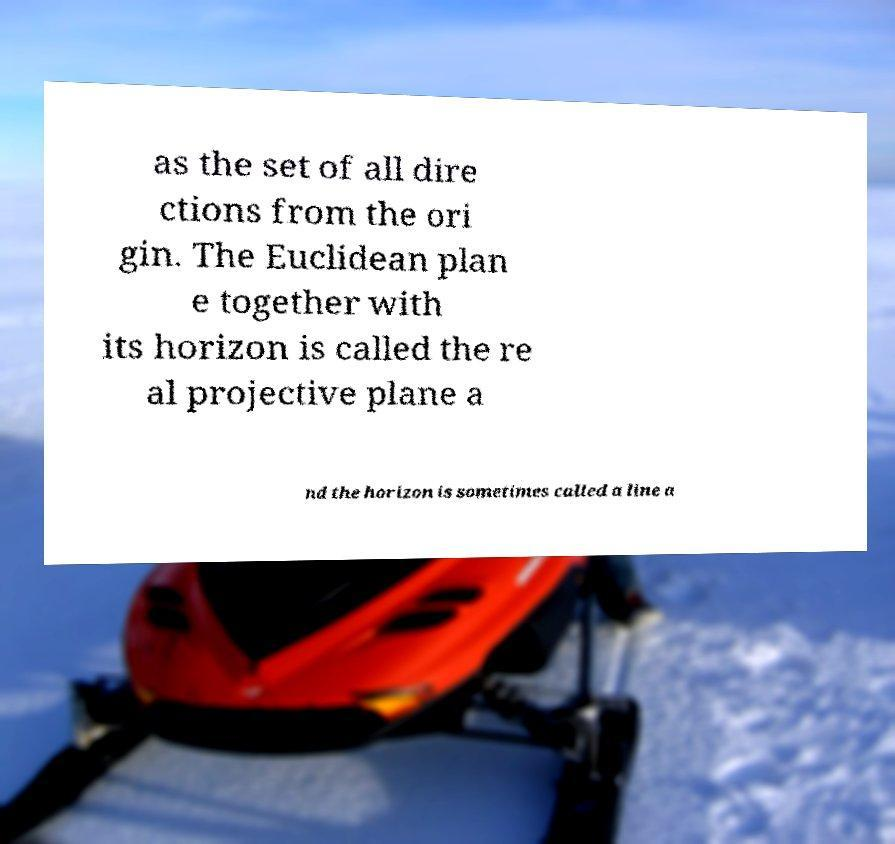Can you read and provide the text displayed in the image?This photo seems to have some interesting text. Can you extract and type it out for me? as the set of all dire ctions from the ori gin. The Euclidean plan e together with its horizon is called the re al projective plane a nd the horizon is sometimes called a line a 